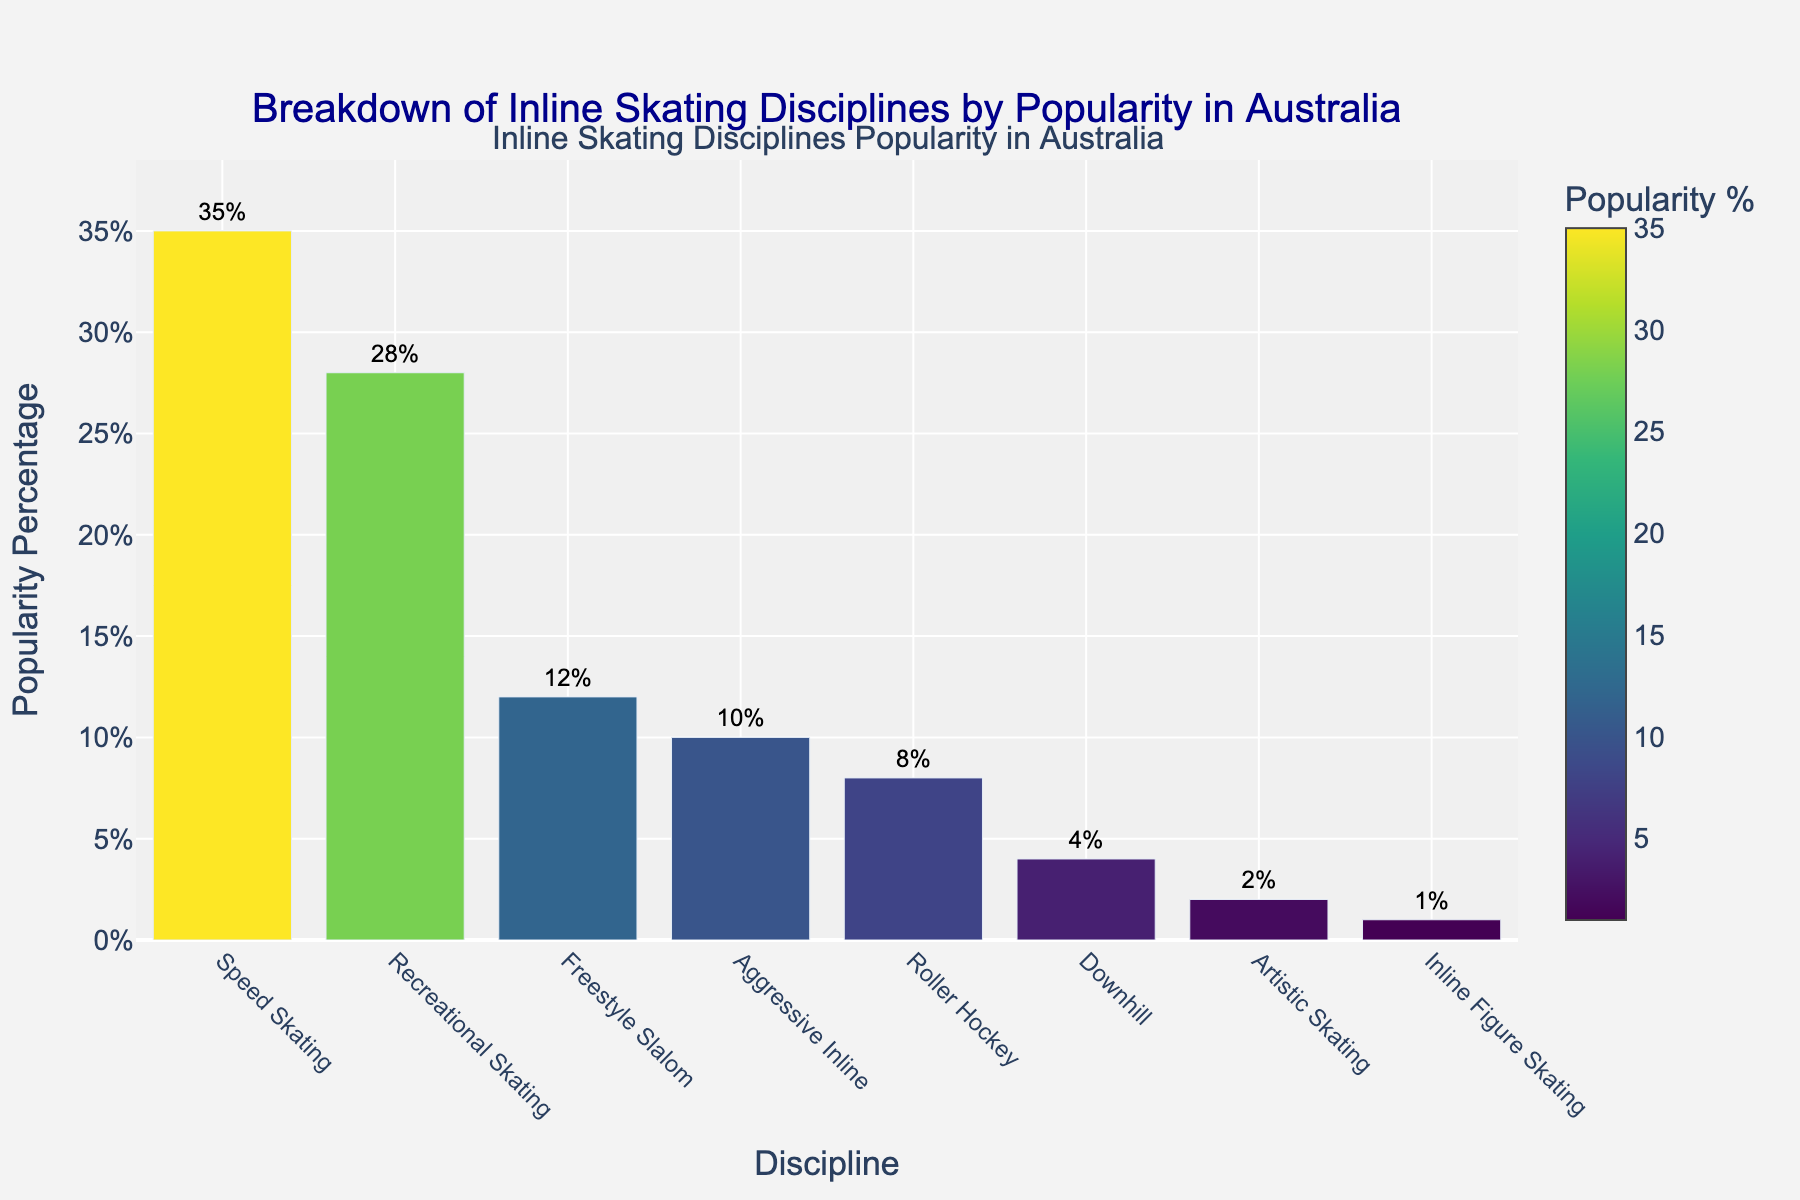Which inline skating discipline is the most popular in Australia? The figure shows that 'Speed Skating' has the highest bar, indicating it has the highest popularity percentage.
Answer: Speed Skating How much more popular is Speed Skating compared to Inline Figure Skating? Speed Skating has a popularity percentage of 35%, while Inline Figure Skating has 1%. The difference is 35% - 1% = 34%.
Answer: 34% What is the combined popularity percentage of Recreational Skating and Aggressive Inline? Recreational Skating has 28%, and Aggressive Inline has 10%. Adding them together, 28% + 10% = 38%.
Answer: 38% Which disciplines have a popularity percentage less than 10%? The bars for Roller Hockey, Downhill, Artistic Skating, and Inline Figure Skating are below the 10% mark on the Y-axis.
Answer: Roller Hockey, Downhill, Artistic Skating, Inline Figure Skating How much more popular is Recreational Skating than Freestyle Slalom? Recreational Skating has 28%, and Freestyle Slalom has 12%. The difference is 28% - 12% = 16%.
Answer: 16% What is the average popularity percentage of all disciplines? Summing the popularity percentages (35 + 28 + 12 + 10 + 8 + 4 + 2 + 1 = 100) and dividing by the number of disciplines (8) gives the average: 100 / 8 = 12.5%.
Answer: 12.5% Which discipline has a popularity percentage closest to 10%? The figure shows Aggressive Inline has a popularity of 10%, which matches the target percentage exactly.
Answer: Aggressive Inline Rank the disciplines from most to least popular. The disciplines ranked by bar height from highest to lowest are Speed Skating, Recreational Skating, Freestyle Slalom, Aggressive Inline, Roller Hockey, Downhill, Artistic Skating, and Inline Figure Skating.
Answer: Speed Skating, Recreational Skating, Freestyle Slalom, Aggressive Inline, Roller Hockey, Downhill, Artistic Skating, Inline Figure Skating What is the total popularity percentage of the three least popular disciplines? The least popular disciplines are Inline Figure Skating (1%), Artistic Skating (2%), and Downhill (4%). Adding them together, 1% + 2% + 4% = 7%.
Answer: 7% Which discipline is represented by the tallest bar with a color closest to yellow? The tallest bar, which represents Speed Skating, has a color closest to the bright end of the Viridis colorscale, which ranges to yellow.
Answer: Speed Skating 